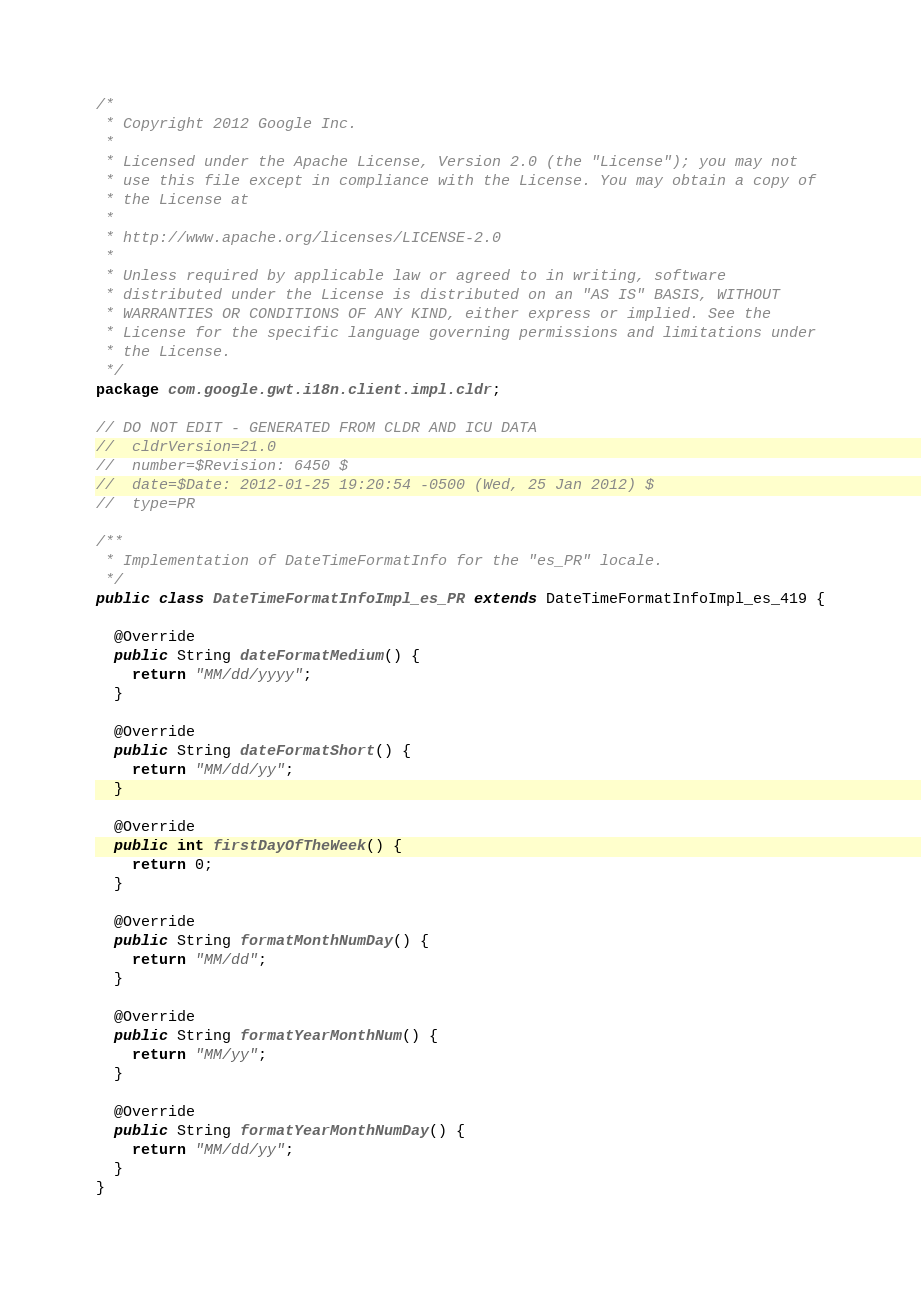Convert code to text. <code><loc_0><loc_0><loc_500><loc_500><_Java_>/*
 * Copyright 2012 Google Inc.
 * 
 * Licensed under the Apache License, Version 2.0 (the "License"); you may not
 * use this file except in compliance with the License. You may obtain a copy of
 * the License at
 * 
 * http://www.apache.org/licenses/LICENSE-2.0
 * 
 * Unless required by applicable law or agreed to in writing, software
 * distributed under the License is distributed on an "AS IS" BASIS, WITHOUT
 * WARRANTIES OR CONDITIONS OF ANY KIND, either express or implied. See the
 * License for the specific language governing permissions and limitations under
 * the License.
 */
package com.google.gwt.i18n.client.impl.cldr;

// DO NOT EDIT - GENERATED FROM CLDR AND ICU DATA
//  cldrVersion=21.0
//  number=$Revision: 6450 $
//  date=$Date: 2012-01-25 19:20:54 -0500 (Wed, 25 Jan 2012) $
//  type=PR

/**
 * Implementation of DateTimeFormatInfo for the "es_PR" locale.
 */
public class DateTimeFormatInfoImpl_es_PR extends DateTimeFormatInfoImpl_es_419 {

  @Override
  public String dateFormatMedium() {
    return "MM/dd/yyyy";
  }

  @Override
  public String dateFormatShort() {
    return "MM/dd/yy";
  }

  @Override
  public int firstDayOfTheWeek() {
    return 0;
  }

  @Override
  public String formatMonthNumDay() {
    return "MM/dd";
  }

  @Override
  public String formatYearMonthNum() {
    return "MM/yy";
  }

  @Override
  public String formatYearMonthNumDay() {
    return "MM/dd/yy";
  }
}
</code> 